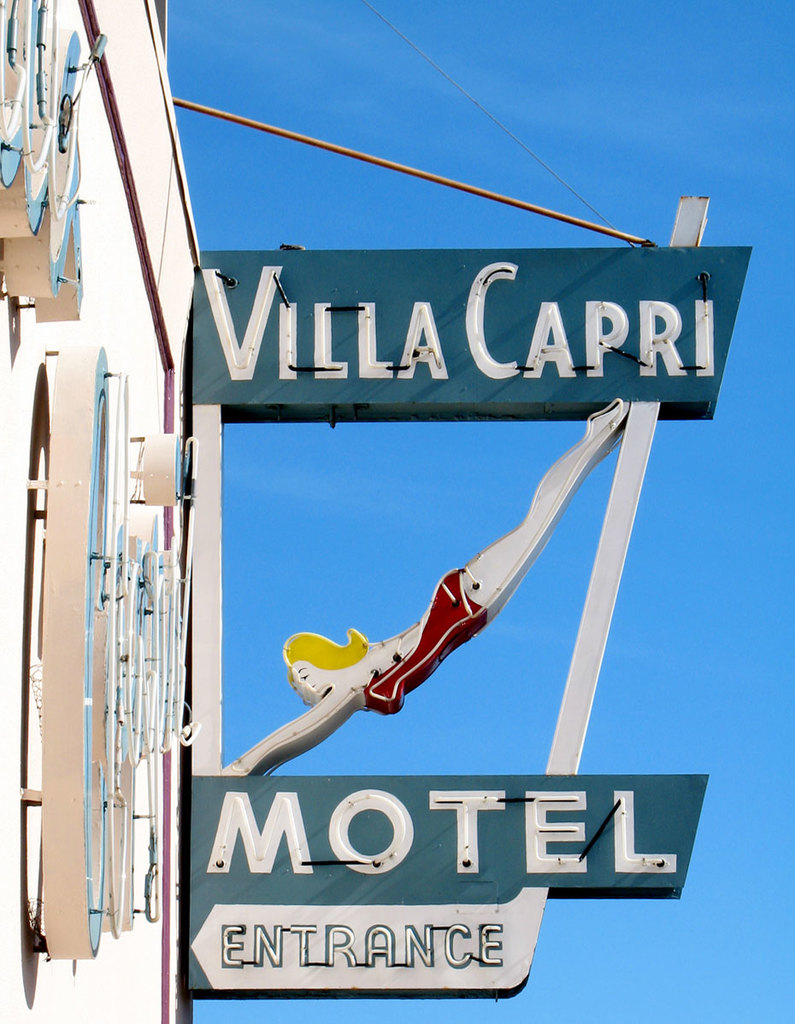Can you describe the main features of this image for me?
 The image showcases a sign for the Villa Capri Motel. The sign is designed in the shape of a large arrow, which is adorned with a mermaid figure, guiding visitors towards the motel entrance. The color scheme of the sign is blue and white. The name "Villa Capri" is written in an elegant cursive font, while the words "Motel Entrance" are displayed in a more straightforward block font. The sign stands out against a backdrop of a clear blue sky, indicating a welcoming atmosphere for incoming guests. 